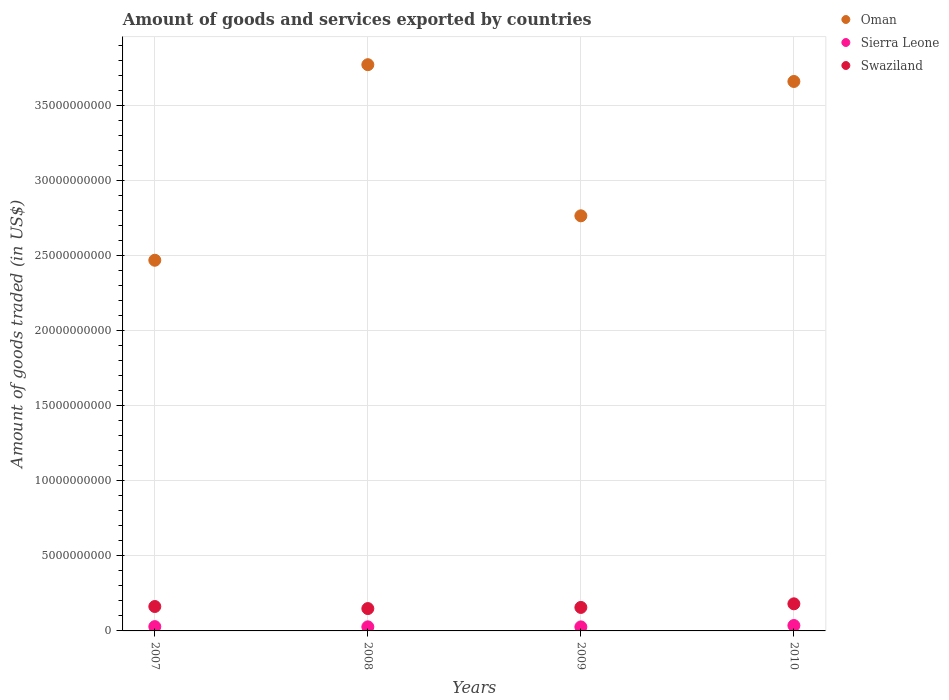What is the total amount of goods and services exported in Sierra Leone in 2007?
Make the answer very short. 2.87e+08. Across all years, what is the maximum total amount of goods and services exported in Sierra Leone?
Keep it short and to the point. 3.60e+08. Across all years, what is the minimum total amount of goods and services exported in Oman?
Ensure brevity in your answer.  2.47e+1. In which year was the total amount of goods and services exported in Swaziland maximum?
Your answer should be compact. 2010. What is the total total amount of goods and services exported in Oman in the graph?
Make the answer very short. 1.27e+11. What is the difference between the total amount of goods and services exported in Oman in 2009 and that in 2010?
Your response must be concise. -8.95e+09. What is the difference between the total amount of goods and services exported in Sierra Leone in 2008 and the total amount of goods and services exported in Swaziland in 2007?
Your response must be concise. -1.35e+09. What is the average total amount of goods and services exported in Swaziland per year?
Your response must be concise. 1.62e+09. In the year 2008, what is the difference between the total amount of goods and services exported in Swaziland and total amount of goods and services exported in Sierra Leone?
Keep it short and to the point. 1.22e+09. In how many years, is the total amount of goods and services exported in Oman greater than 25000000000 US$?
Make the answer very short. 3. What is the ratio of the total amount of goods and services exported in Swaziland in 2007 to that in 2009?
Your response must be concise. 1.04. What is the difference between the highest and the second highest total amount of goods and services exported in Swaziland?
Ensure brevity in your answer.  1.79e+08. What is the difference between the highest and the lowest total amount of goods and services exported in Sierra Leone?
Ensure brevity in your answer.  9.25e+07. Is the total amount of goods and services exported in Sierra Leone strictly less than the total amount of goods and services exported in Swaziland over the years?
Offer a very short reply. Yes. How many years are there in the graph?
Provide a succinct answer. 4. What is the difference between two consecutive major ticks on the Y-axis?
Ensure brevity in your answer.  5.00e+09. Where does the legend appear in the graph?
Give a very brief answer. Top right. How are the legend labels stacked?
Your response must be concise. Vertical. What is the title of the graph?
Make the answer very short. Amount of goods and services exported by countries. Does "Ukraine" appear as one of the legend labels in the graph?
Provide a short and direct response. No. What is the label or title of the X-axis?
Your answer should be very brief. Years. What is the label or title of the Y-axis?
Make the answer very short. Amount of goods traded (in US$). What is the Amount of goods traded (in US$) of Oman in 2007?
Offer a terse response. 2.47e+1. What is the Amount of goods traded (in US$) in Sierra Leone in 2007?
Provide a succinct answer. 2.87e+08. What is the Amount of goods traded (in US$) of Swaziland in 2007?
Ensure brevity in your answer.  1.63e+09. What is the Amount of goods traded (in US$) in Oman in 2008?
Your answer should be compact. 3.77e+1. What is the Amount of goods traded (in US$) of Sierra Leone in 2008?
Offer a terse response. 2.71e+08. What is the Amount of goods traded (in US$) of Swaziland in 2008?
Give a very brief answer. 1.49e+09. What is the Amount of goods traded (in US$) of Oman in 2009?
Your answer should be compact. 2.77e+1. What is the Amount of goods traded (in US$) of Sierra Leone in 2009?
Your answer should be very brief. 2.68e+08. What is the Amount of goods traded (in US$) in Swaziland in 2009?
Offer a terse response. 1.56e+09. What is the Amount of goods traded (in US$) of Oman in 2010?
Give a very brief answer. 3.66e+1. What is the Amount of goods traded (in US$) of Sierra Leone in 2010?
Ensure brevity in your answer.  3.60e+08. What is the Amount of goods traded (in US$) in Swaziland in 2010?
Provide a succinct answer. 1.81e+09. Across all years, what is the maximum Amount of goods traded (in US$) in Oman?
Your answer should be compact. 3.77e+1. Across all years, what is the maximum Amount of goods traded (in US$) of Sierra Leone?
Your response must be concise. 3.60e+08. Across all years, what is the maximum Amount of goods traded (in US$) of Swaziland?
Ensure brevity in your answer.  1.81e+09. Across all years, what is the minimum Amount of goods traded (in US$) in Oman?
Your response must be concise. 2.47e+1. Across all years, what is the minimum Amount of goods traded (in US$) in Sierra Leone?
Offer a terse response. 2.68e+08. Across all years, what is the minimum Amount of goods traded (in US$) in Swaziland?
Make the answer very short. 1.49e+09. What is the total Amount of goods traded (in US$) in Oman in the graph?
Make the answer very short. 1.27e+11. What is the total Amount of goods traded (in US$) of Sierra Leone in the graph?
Make the answer very short. 1.19e+09. What is the total Amount of goods traded (in US$) of Swaziland in the graph?
Your answer should be very brief. 6.49e+09. What is the difference between the Amount of goods traded (in US$) of Oman in 2007 and that in 2008?
Provide a short and direct response. -1.30e+1. What is the difference between the Amount of goods traded (in US$) of Sierra Leone in 2007 and that in 2008?
Offer a terse response. 1.57e+07. What is the difference between the Amount of goods traded (in US$) of Swaziland in 2007 and that in 2008?
Provide a succinct answer. 1.37e+08. What is the difference between the Amount of goods traded (in US$) of Oman in 2007 and that in 2009?
Ensure brevity in your answer.  -2.96e+09. What is the difference between the Amount of goods traded (in US$) of Sierra Leone in 2007 and that in 2009?
Give a very brief answer. 1.95e+07. What is the difference between the Amount of goods traded (in US$) of Swaziland in 2007 and that in 2009?
Keep it short and to the point. 6.09e+07. What is the difference between the Amount of goods traded (in US$) in Oman in 2007 and that in 2010?
Offer a very short reply. -1.19e+1. What is the difference between the Amount of goods traded (in US$) of Sierra Leone in 2007 and that in 2010?
Provide a succinct answer. -7.30e+07. What is the difference between the Amount of goods traded (in US$) in Swaziland in 2007 and that in 2010?
Your answer should be very brief. -1.79e+08. What is the difference between the Amount of goods traded (in US$) of Oman in 2008 and that in 2009?
Your answer should be very brief. 1.01e+1. What is the difference between the Amount of goods traded (in US$) of Sierra Leone in 2008 and that in 2009?
Offer a terse response. 3.85e+06. What is the difference between the Amount of goods traded (in US$) of Swaziland in 2008 and that in 2009?
Your response must be concise. -7.58e+07. What is the difference between the Amount of goods traded (in US$) in Oman in 2008 and that in 2010?
Your response must be concise. 1.12e+09. What is the difference between the Amount of goods traded (in US$) of Sierra Leone in 2008 and that in 2010?
Offer a very short reply. -8.87e+07. What is the difference between the Amount of goods traded (in US$) in Swaziland in 2008 and that in 2010?
Offer a terse response. -3.16e+08. What is the difference between the Amount of goods traded (in US$) in Oman in 2009 and that in 2010?
Keep it short and to the point. -8.95e+09. What is the difference between the Amount of goods traded (in US$) of Sierra Leone in 2009 and that in 2010?
Offer a very short reply. -9.25e+07. What is the difference between the Amount of goods traded (in US$) in Swaziland in 2009 and that in 2010?
Keep it short and to the point. -2.40e+08. What is the difference between the Amount of goods traded (in US$) of Oman in 2007 and the Amount of goods traded (in US$) of Sierra Leone in 2008?
Keep it short and to the point. 2.44e+1. What is the difference between the Amount of goods traded (in US$) in Oman in 2007 and the Amount of goods traded (in US$) in Swaziland in 2008?
Your response must be concise. 2.32e+1. What is the difference between the Amount of goods traded (in US$) in Sierra Leone in 2007 and the Amount of goods traded (in US$) in Swaziland in 2008?
Provide a succinct answer. -1.20e+09. What is the difference between the Amount of goods traded (in US$) in Oman in 2007 and the Amount of goods traded (in US$) in Sierra Leone in 2009?
Offer a very short reply. 2.44e+1. What is the difference between the Amount of goods traded (in US$) in Oman in 2007 and the Amount of goods traded (in US$) in Swaziland in 2009?
Keep it short and to the point. 2.31e+1. What is the difference between the Amount of goods traded (in US$) in Sierra Leone in 2007 and the Amount of goods traded (in US$) in Swaziland in 2009?
Make the answer very short. -1.28e+09. What is the difference between the Amount of goods traded (in US$) of Oman in 2007 and the Amount of goods traded (in US$) of Sierra Leone in 2010?
Make the answer very short. 2.43e+1. What is the difference between the Amount of goods traded (in US$) in Oman in 2007 and the Amount of goods traded (in US$) in Swaziland in 2010?
Your answer should be very brief. 2.29e+1. What is the difference between the Amount of goods traded (in US$) in Sierra Leone in 2007 and the Amount of goods traded (in US$) in Swaziland in 2010?
Make the answer very short. -1.52e+09. What is the difference between the Amount of goods traded (in US$) of Oman in 2008 and the Amount of goods traded (in US$) of Sierra Leone in 2009?
Give a very brief answer. 3.75e+1. What is the difference between the Amount of goods traded (in US$) in Oman in 2008 and the Amount of goods traded (in US$) in Swaziland in 2009?
Provide a succinct answer. 3.62e+1. What is the difference between the Amount of goods traded (in US$) of Sierra Leone in 2008 and the Amount of goods traded (in US$) of Swaziland in 2009?
Your response must be concise. -1.29e+09. What is the difference between the Amount of goods traded (in US$) of Oman in 2008 and the Amount of goods traded (in US$) of Sierra Leone in 2010?
Your answer should be very brief. 3.74e+1. What is the difference between the Amount of goods traded (in US$) of Oman in 2008 and the Amount of goods traded (in US$) of Swaziland in 2010?
Your response must be concise. 3.59e+1. What is the difference between the Amount of goods traded (in US$) of Sierra Leone in 2008 and the Amount of goods traded (in US$) of Swaziland in 2010?
Your answer should be very brief. -1.53e+09. What is the difference between the Amount of goods traded (in US$) of Oman in 2009 and the Amount of goods traded (in US$) of Sierra Leone in 2010?
Provide a succinct answer. 2.73e+1. What is the difference between the Amount of goods traded (in US$) in Oman in 2009 and the Amount of goods traded (in US$) in Swaziland in 2010?
Provide a short and direct response. 2.58e+1. What is the difference between the Amount of goods traded (in US$) in Sierra Leone in 2009 and the Amount of goods traded (in US$) in Swaziland in 2010?
Provide a succinct answer. -1.54e+09. What is the average Amount of goods traded (in US$) in Oman per year?
Give a very brief answer. 3.17e+1. What is the average Amount of goods traded (in US$) in Sierra Leone per year?
Your response must be concise. 2.97e+08. What is the average Amount of goods traded (in US$) of Swaziland per year?
Your answer should be compact. 1.62e+09. In the year 2007, what is the difference between the Amount of goods traded (in US$) of Oman and Amount of goods traded (in US$) of Sierra Leone?
Provide a short and direct response. 2.44e+1. In the year 2007, what is the difference between the Amount of goods traded (in US$) in Oman and Amount of goods traded (in US$) in Swaziland?
Your answer should be very brief. 2.31e+1. In the year 2007, what is the difference between the Amount of goods traded (in US$) of Sierra Leone and Amount of goods traded (in US$) of Swaziland?
Your answer should be very brief. -1.34e+09. In the year 2008, what is the difference between the Amount of goods traded (in US$) in Oman and Amount of goods traded (in US$) in Sierra Leone?
Provide a short and direct response. 3.74e+1. In the year 2008, what is the difference between the Amount of goods traded (in US$) in Oman and Amount of goods traded (in US$) in Swaziland?
Your answer should be compact. 3.62e+1. In the year 2008, what is the difference between the Amount of goods traded (in US$) in Sierra Leone and Amount of goods traded (in US$) in Swaziland?
Your response must be concise. -1.22e+09. In the year 2009, what is the difference between the Amount of goods traded (in US$) in Oman and Amount of goods traded (in US$) in Sierra Leone?
Give a very brief answer. 2.74e+1. In the year 2009, what is the difference between the Amount of goods traded (in US$) in Oman and Amount of goods traded (in US$) in Swaziland?
Provide a succinct answer. 2.61e+1. In the year 2009, what is the difference between the Amount of goods traded (in US$) in Sierra Leone and Amount of goods traded (in US$) in Swaziland?
Make the answer very short. -1.30e+09. In the year 2010, what is the difference between the Amount of goods traded (in US$) of Oman and Amount of goods traded (in US$) of Sierra Leone?
Offer a very short reply. 3.62e+1. In the year 2010, what is the difference between the Amount of goods traded (in US$) in Oman and Amount of goods traded (in US$) in Swaziland?
Make the answer very short. 3.48e+1. In the year 2010, what is the difference between the Amount of goods traded (in US$) of Sierra Leone and Amount of goods traded (in US$) of Swaziland?
Make the answer very short. -1.45e+09. What is the ratio of the Amount of goods traded (in US$) of Oman in 2007 to that in 2008?
Keep it short and to the point. 0.65. What is the ratio of the Amount of goods traded (in US$) in Sierra Leone in 2007 to that in 2008?
Ensure brevity in your answer.  1.06. What is the ratio of the Amount of goods traded (in US$) of Swaziland in 2007 to that in 2008?
Ensure brevity in your answer.  1.09. What is the ratio of the Amount of goods traded (in US$) in Oman in 2007 to that in 2009?
Ensure brevity in your answer.  0.89. What is the ratio of the Amount of goods traded (in US$) of Sierra Leone in 2007 to that in 2009?
Provide a succinct answer. 1.07. What is the ratio of the Amount of goods traded (in US$) of Swaziland in 2007 to that in 2009?
Offer a very short reply. 1.04. What is the ratio of the Amount of goods traded (in US$) in Oman in 2007 to that in 2010?
Provide a succinct answer. 0.67. What is the ratio of the Amount of goods traded (in US$) in Sierra Leone in 2007 to that in 2010?
Make the answer very short. 0.8. What is the ratio of the Amount of goods traded (in US$) in Swaziland in 2007 to that in 2010?
Offer a very short reply. 0.9. What is the ratio of the Amount of goods traded (in US$) of Oman in 2008 to that in 2009?
Your answer should be very brief. 1.36. What is the ratio of the Amount of goods traded (in US$) in Sierra Leone in 2008 to that in 2009?
Offer a terse response. 1.01. What is the ratio of the Amount of goods traded (in US$) in Swaziland in 2008 to that in 2009?
Your answer should be very brief. 0.95. What is the ratio of the Amount of goods traded (in US$) of Oman in 2008 to that in 2010?
Make the answer very short. 1.03. What is the ratio of the Amount of goods traded (in US$) of Sierra Leone in 2008 to that in 2010?
Provide a short and direct response. 0.75. What is the ratio of the Amount of goods traded (in US$) of Swaziland in 2008 to that in 2010?
Make the answer very short. 0.82. What is the ratio of the Amount of goods traded (in US$) in Oman in 2009 to that in 2010?
Your answer should be compact. 0.76. What is the ratio of the Amount of goods traded (in US$) in Sierra Leone in 2009 to that in 2010?
Your answer should be compact. 0.74. What is the ratio of the Amount of goods traded (in US$) in Swaziland in 2009 to that in 2010?
Offer a very short reply. 0.87. What is the difference between the highest and the second highest Amount of goods traded (in US$) of Oman?
Offer a very short reply. 1.12e+09. What is the difference between the highest and the second highest Amount of goods traded (in US$) in Sierra Leone?
Your response must be concise. 7.30e+07. What is the difference between the highest and the second highest Amount of goods traded (in US$) of Swaziland?
Your response must be concise. 1.79e+08. What is the difference between the highest and the lowest Amount of goods traded (in US$) of Oman?
Your answer should be compact. 1.30e+1. What is the difference between the highest and the lowest Amount of goods traded (in US$) in Sierra Leone?
Provide a succinct answer. 9.25e+07. What is the difference between the highest and the lowest Amount of goods traded (in US$) in Swaziland?
Your answer should be compact. 3.16e+08. 